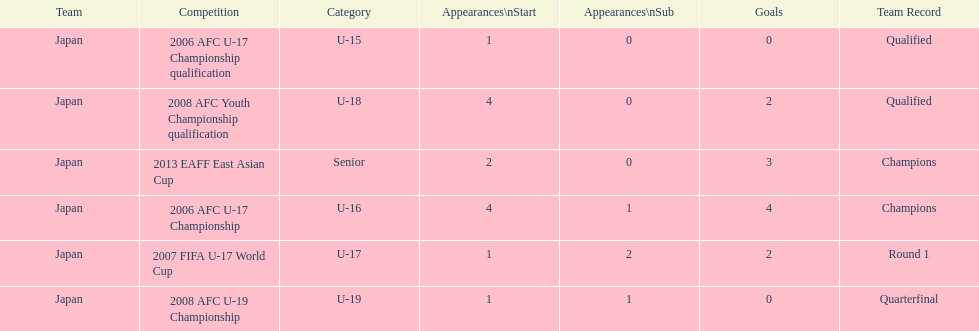How many total goals were scored? 11. Could you help me parse every detail presented in this table? {'header': ['Team', 'Competition', 'Category', 'Appearances\\nStart', 'Appearances\\nSub', 'Goals', 'Team Record'], 'rows': [['Japan', '2006 AFC U-17 Championship qualification', 'U-15', '1', '0', '0', 'Qualified'], ['Japan', '2008 AFC Youth Championship qualification', 'U-18', '4', '0', '2', 'Qualified'], ['Japan', '2013 EAFF East Asian Cup', 'Senior', '2', '0', '3', 'Champions'], ['Japan', '2006 AFC U-17 Championship', 'U-16', '4', '1', '4', 'Champions'], ['Japan', '2007 FIFA U-17 World Cup', 'U-17', '1', '2', '2', 'Round 1'], ['Japan', '2008 AFC U-19 Championship', 'U-19', '1', '1', '0', 'Quarterfinal']]} 